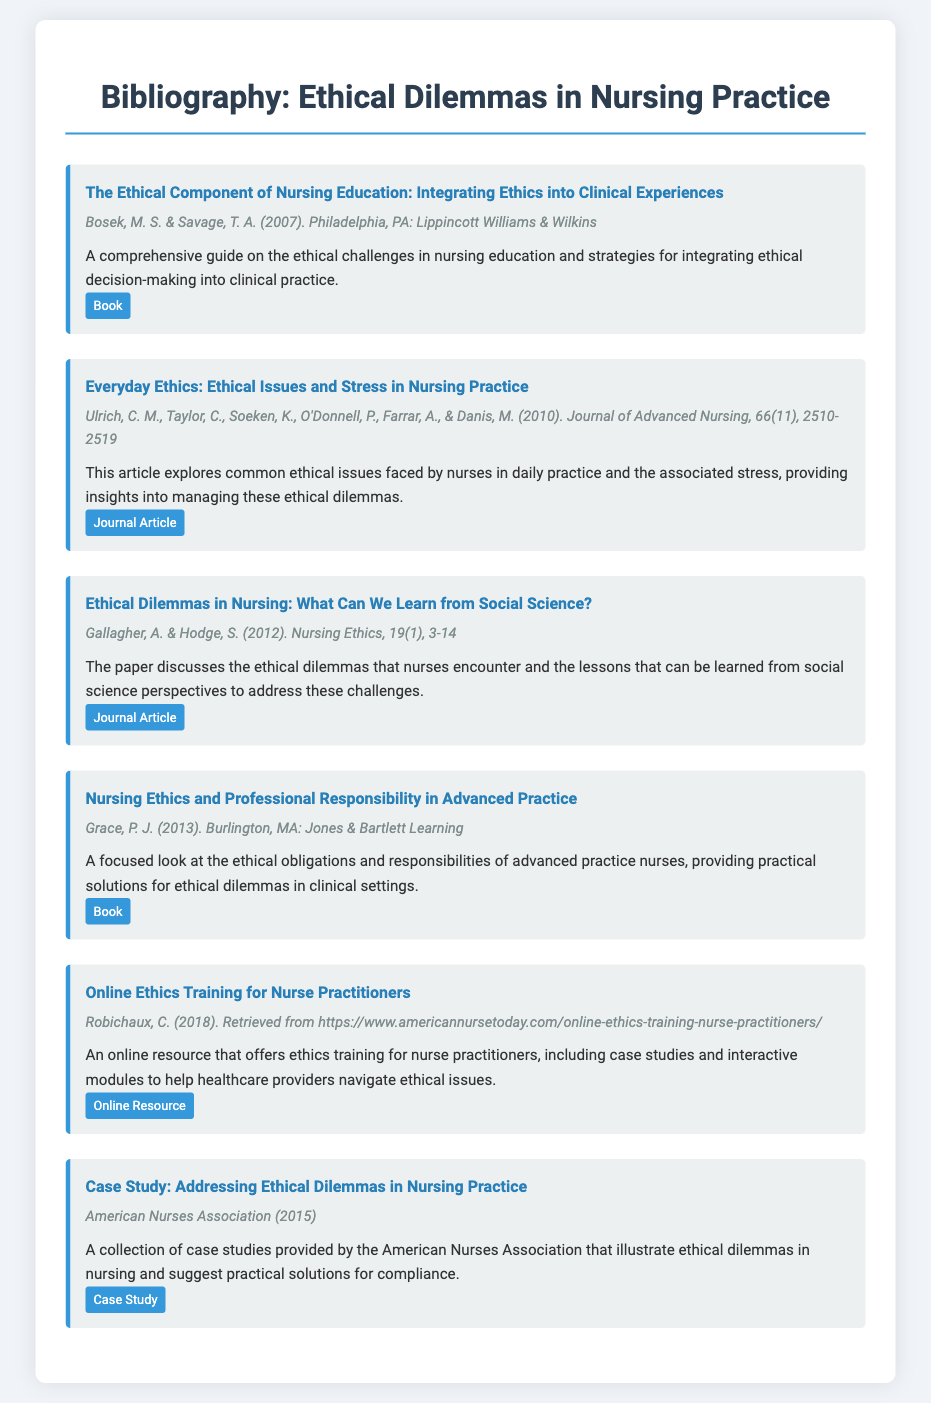What is the title of the first entry? The title of the first entry is the name of the work listed at the top of the entry.
Answer: The Ethical Component of Nursing Education: Integrating Ethics into Clinical Experiences Who are the authors of the second entry? The authors of the second entry are listed under the entry meta section and provide the key contributors to the work.
Answer: Ulrich, C. M., Taylor, C., Soeken, K., O'Donnell, P., Farrar, A., & Danis, M What year was the third entry published? The year published is included in the entry meta and indicates when the work became available to the public.
Answer: 2012 What type of resource is the fifth entry? The type of resource is identified by a tag at the end of the entry, specifying the format of the work described.
Answer: Online Resource What ethical challenge does the fourth entry focus on? The focus of the fourth entry is found in the description, highlighting the specific ethical issues that advanced practice nurses face.
Answer: Ethical obligations and responsibilities How many articles are included in the bibliography? The total number of articles can be calculated by counting the entries categorized under journal articles in the document.
Answer: 3 What does the sixth entry provide? The sixth entry lists its main purpose and type in the description, emphasizing what readers can expect from it.
Answer: Case studies Which publisher released the book in the first entry? The publisher is noted towards the end of the entry, indicating who published the work.
Answer: Lippincott Williams & Wilkins 